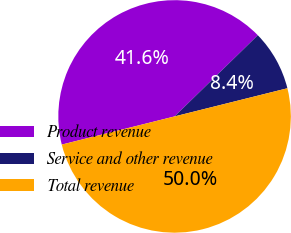Convert chart to OTSL. <chart><loc_0><loc_0><loc_500><loc_500><pie_chart><fcel>Product revenue<fcel>Service and other revenue<fcel>Total revenue<nl><fcel>41.59%<fcel>8.41%<fcel>50.0%<nl></chart> 